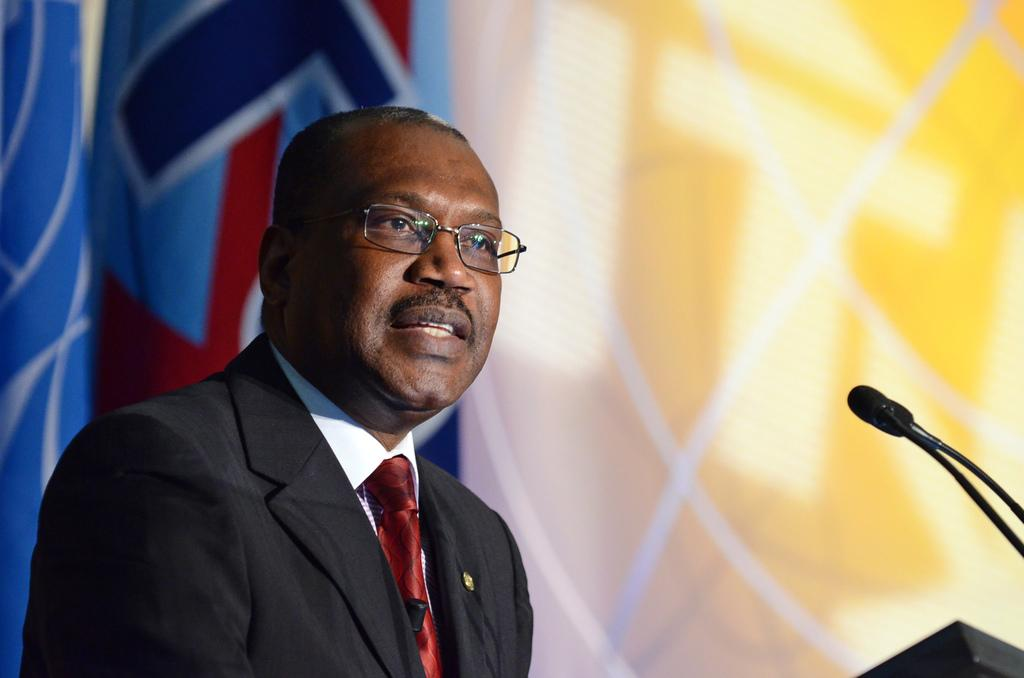What is the man in the image doing? The man is standing in the image. What is the man wearing? The man is wearing a suit. What object is in front of the man? There is a podium in front of the man. What device is present for the man to speak into? There is a microphone in the image. What type of cream is being used to wash the man's hands in the image? There is no cream or hand-washing activity present in the image. 